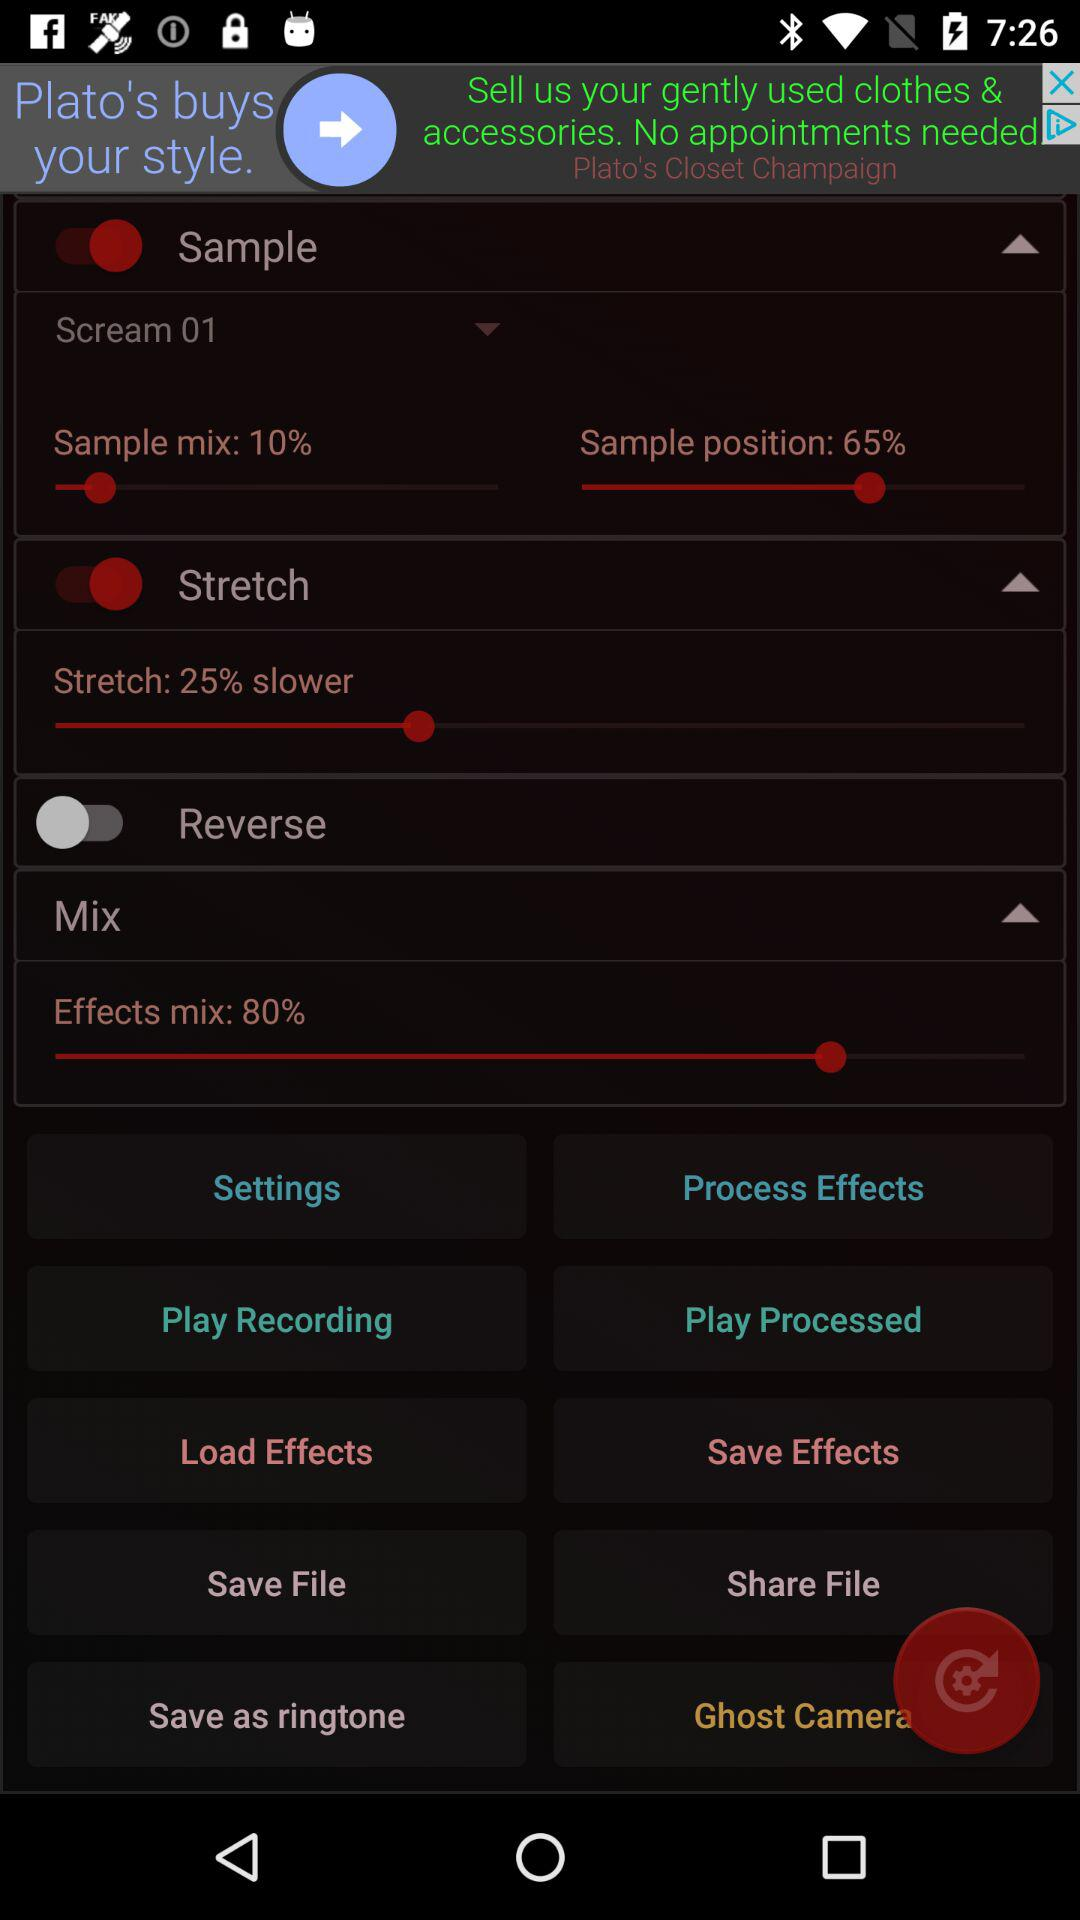What is the status of the "Reverse"? The status is "off". 